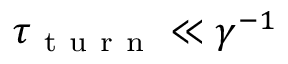<formula> <loc_0><loc_0><loc_500><loc_500>\tau _ { t u r n } \ll \gamma ^ { - 1 }</formula> 